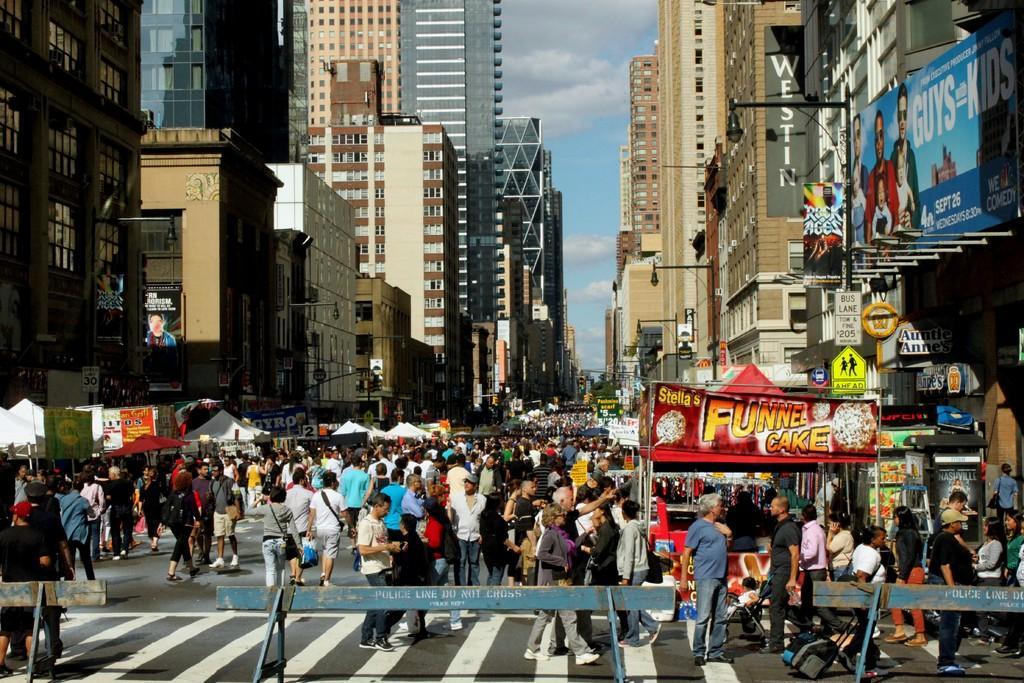Describe this image in one or two sentences. There is an event and there are plenty of stalls kept beside the road and there is a huge crowd on the road and behind the stalls there are very tall buildings and in the background there is a sky. 